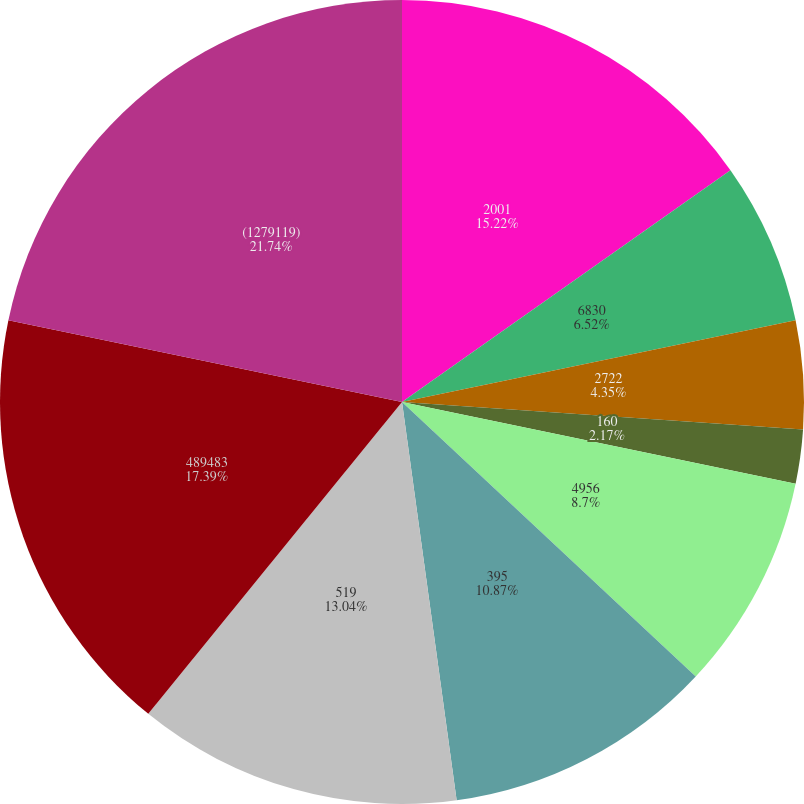<chart> <loc_0><loc_0><loc_500><loc_500><pie_chart><fcel>2001<fcel>6830<fcel>2722<fcel>1570<fcel>160<fcel>4956<fcel>395<fcel>519<fcel>489483<fcel>(1279119)<nl><fcel>15.22%<fcel>6.52%<fcel>4.35%<fcel>0.0%<fcel>2.17%<fcel>8.7%<fcel>10.87%<fcel>13.04%<fcel>17.39%<fcel>21.74%<nl></chart> 